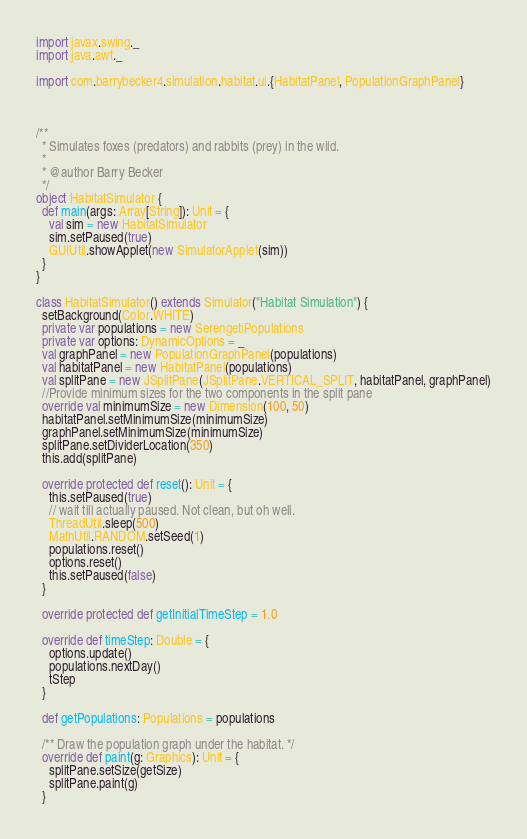Convert code to text. <code><loc_0><loc_0><loc_500><loc_500><_Scala_>import javax.swing._
import java.awt._

import com.barrybecker4.simulation.habitat.ui.{HabitatPanel, PopulationGraphPanel}



/**
  * Simulates foxes (predators) and rabbits (prey) in the wild.
  *
  * @author Barry Becker
  */
object HabitatSimulator {
  def main(args: Array[String]): Unit = {
    val sim = new HabitatSimulator
    sim.setPaused(true)
    GUIUtil.showApplet(new SimulatorApplet(sim))
  }
}

class HabitatSimulator() extends Simulator("Habitat Simulation") {
  setBackground(Color.WHITE)
  private var populations = new SerengetiPopulations
  private var options: DynamicOptions = _
  val graphPanel = new PopulationGraphPanel(populations)
  val habitatPanel = new HabitatPanel(populations)
  val splitPane = new JSplitPane(JSplitPane.VERTICAL_SPLIT, habitatPanel, graphPanel)
  //Provide minimum sizes for the two components in the split pane
  override val minimumSize = new Dimension(100, 50)
  habitatPanel.setMinimumSize(minimumSize)
  graphPanel.setMinimumSize(minimumSize)
  splitPane.setDividerLocation(350)
  this.add(splitPane)

  override protected def reset(): Unit = {
    this.setPaused(true)
    // wait till actually paused. Not clean, but oh well.
    ThreadUtil.sleep(500)
    MathUtil.RANDOM.setSeed(1)
    populations.reset()
    options.reset()
    this.setPaused(false)
  }

  override protected def getInitialTimeStep = 1.0

  override def timeStep: Double = {
    options.update()
    populations.nextDay()
    tStep
  }

  def getPopulations: Populations = populations

  /** Draw the population graph under the habitat. */
  override def paint(g: Graphics): Unit = {
    splitPane.setSize(getSize)
    splitPane.paint(g)
  }
</code> 